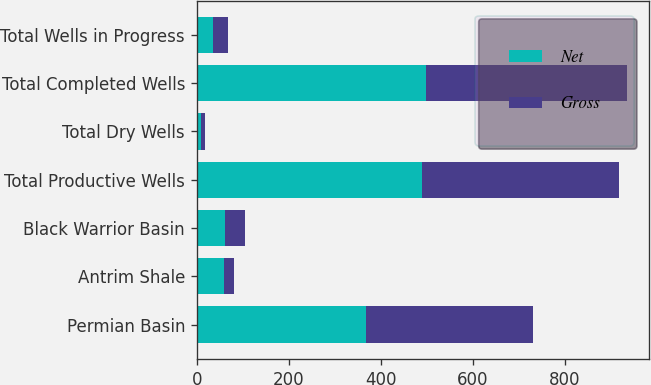<chart> <loc_0><loc_0><loc_500><loc_500><stacked_bar_chart><ecel><fcel>Permian Basin<fcel>Antrim Shale<fcel>Black Warrior Basin<fcel>Total Productive Wells<fcel>Total Dry Wells<fcel>Total Completed Wells<fcel>Total Wells in Progress<nl><fcel>Net<fcel>369<fcel>59<fcel>61<fcel>489<fcel>9<fcel>498<fcel>35<nl><fcel>Gross<fcel>363.5<fcel>22.7<fcel>42.9<fcel>429.1<fcel>9<fcel>438.1<fcel>33.1<nl></chart> 